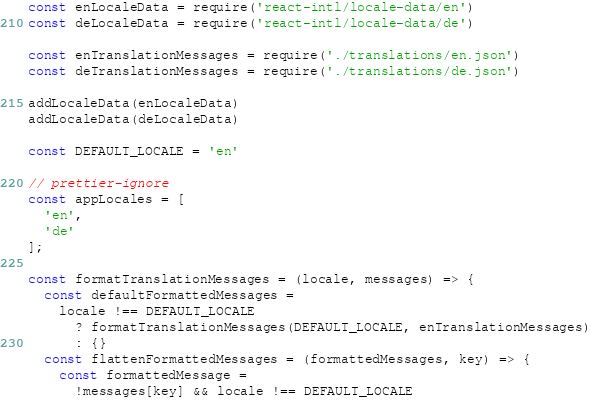<code> <loc_0><loc_0><loc_500><loc_500><_JavaScript_>const enLocaleData = require('react-intl/locale-data/en')
const deLocaleData = require('react-intl/locale-data/de')

const enTranslationMessages = require('./translations/en.json')
const deTranslationMessages = require('./translations/de.json')

addLocaleData(enLocaleData)
addLocaleData(deLocaleData)

const DEFAULT_LOCALE = 'en'

// prettier-ignore
const appLocales = [
  'en',
  'de'
];

const formatTranslationMessages = (locale, messages) => {
  const defaultFormattedMessages =
    locale !== DEFAULT_LOCALE
      ? formatTranslationMessages(DEFAULT_LOCALE, enTranslationMessages)
      : {}
  const flattenFormattedMessages = (formattedMessages, key) => {
    const formattedMessage =
      !messages[key] && locale !== DEFAULT_LOCALE</code> 